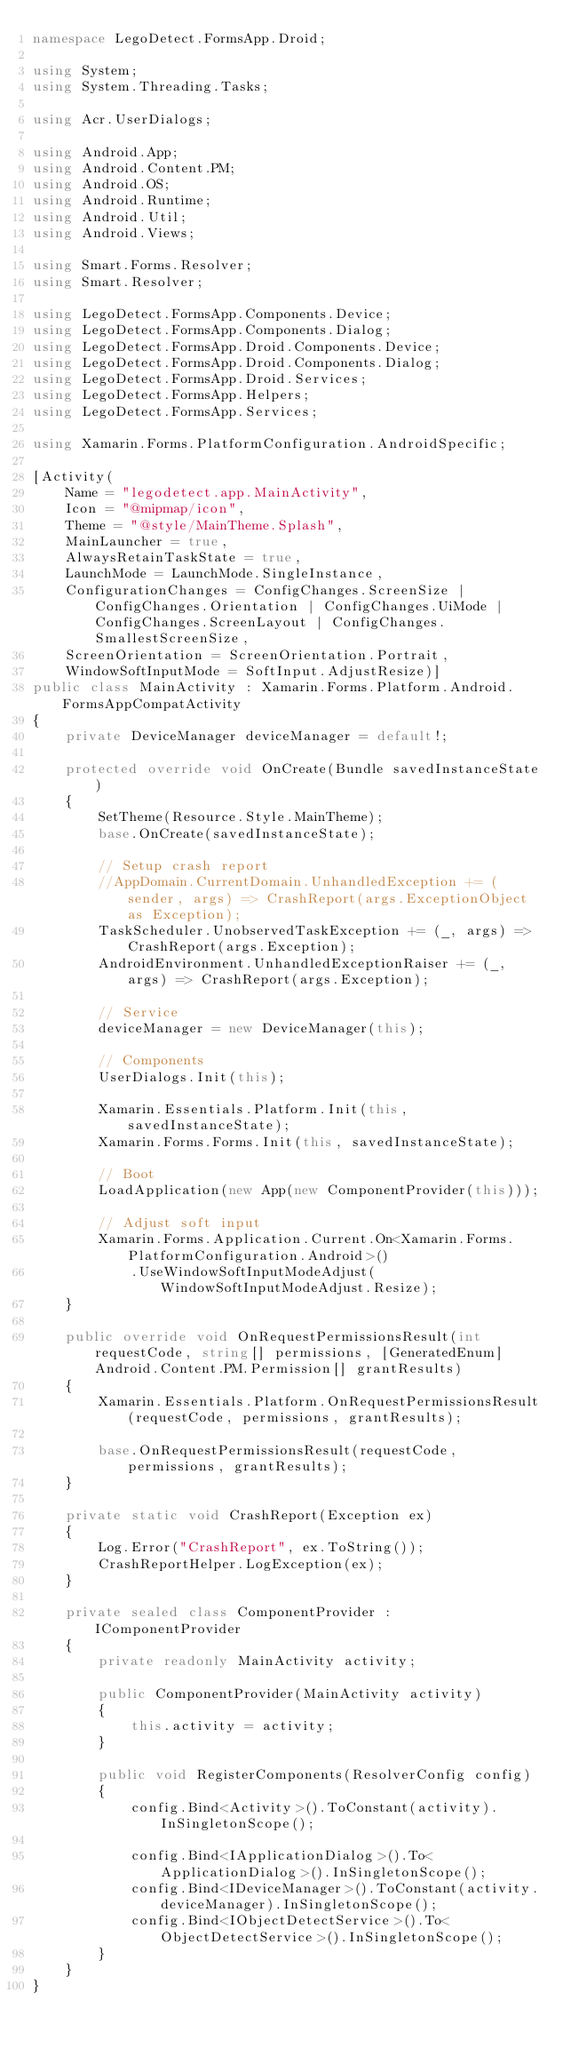<code> <loc_0><loc_0><loc_500><loc_500><_C#_>namespace LegoDetect.FormsApp.Droid;

using System;
using System.Threading.Tasks;

using Acr.UserDialogs;

using Android.App;
using Android.Content.PM;
using Android.OS;
using Android.Runtime;
using Android.Util;
using Android.Views;

using Smart.Forms.Resolver;
using Smart.Resolver;

using LegoDetect.FormsApp.Components.Device;
using LegoDetect.FormsApp.Components.Dialog;
using LegoDetect.FormsApp.Droid.Components.Device;
using LegoDetect.FormsApp.Droid.Components.Dialog;
using LegoDetect.FormsApp.Droid.Services;
using LegoDetect.FormsApp.Helpers;
using LegoDetect.FormsApp.Services;

using Xamarin.Forms.PlatformConfiguration.AndroidSpecific;

[Activity(
    Name = "legodetect.app.MainActivity",
    Icon = "@mipmap/icon",
    Theme = "@style/MainTheme.Splash",
    MainLauncher = true,
    AlwaysRetainTaskState = true,
    LaunchMode = LaunchMode.SingleInstance,
    ConfigurationChanges = ConfigChanges.ScreenSize | ConfigChanges.Orientation | ConfigChanges.UiMode | ConfigChanges.ScreenLayout | ConfigChanges.SmallestScreenSize,
    ScreenOrientation = ScreenOrientation.Portrait,
    WindowSoftInputMode = SoftInput.AdjustResize)]
public class MainActivity : Xamarin.Forms.Platform.Android.FormsAppCompatActivity
{
    private DeviceManager deviceManager = default!;

    protected override void OnCreate(Bundle savedInstanceState)
    {
        SetTheme(Resource.Style.MainTheme);
        base.OnCreate(savedInstanceState);

        // Setup crash report
        //AppDomain.CurrentDomain.UnhandledException += (sender, args) => CrashReport(args.ExceptionObject as Exception);
        TaskScheduler.UnobservedTaskException += (_, args) => CrashReport(args.Exception);
        AndroidEnvironment.UnhandledExceptionRaiser += (_, args) => CrashReport(args.Exception);

        // Service
        deviceManager = new DeviceManager(this);

        // Components
        UserDialogs.Init(this);

        Xamarin.Essentials.Platform.Init(this, savedInstanceState);
        Xamarin.Forms.Forms.Init(this, savedInstanceState);

        // Boot
        LoadApplication(new App(new ComponentProvider(this)));

        // Adjust soft input
        Xamarin.Forms.Application.Current.On<Xamarin.Forms.PlatformConfiguration.Android>()
            .UseWindowSoftInputModeAdjust(WindowSoftInputModeAdjust.Resize);
    }

    public override void OnRequestPermissionsResult(int requestCode, string[] permissions, [GeneratedEnum] Android.Content.PM.Permission[] grantResults)
    {
        Xamarin.Essentials.Platform.OnRequestPermissionsResult(requestCode, permissions, grantResults);

        base.OnRequestPermissionsResult(requestCode, permissions, grantResults);
    }

    private static void CrashReport(Exception ex)
    {
        Log.Error("CrashReport", ex.ToString());
        CrashReportHelper.LogException(ex);
    }

    private sealed class ComponentProvider : IComponentProvider
    {
        private readonly MainActivity activity;

        public ComponentProvider(MainActivity activity)
        {
            this.activity = activity;
        }

        public void RegisterComponents(ResolverConfig config)
        {
            config.Bind<Activity>().ToConstant(activity).InSingletonScope();

            config.Bind<IApplicationDialog>().To<ApplicationDialog>().InSingletonScope();
            config.Bind<IDeviceManager>().ToConstant(activity.deviceManager).InSingletonScope();
            config.Bind<IObjectDetectService>().To<ObjectDetectService>().InSingletonScope();
        }
    }
}
</code> 